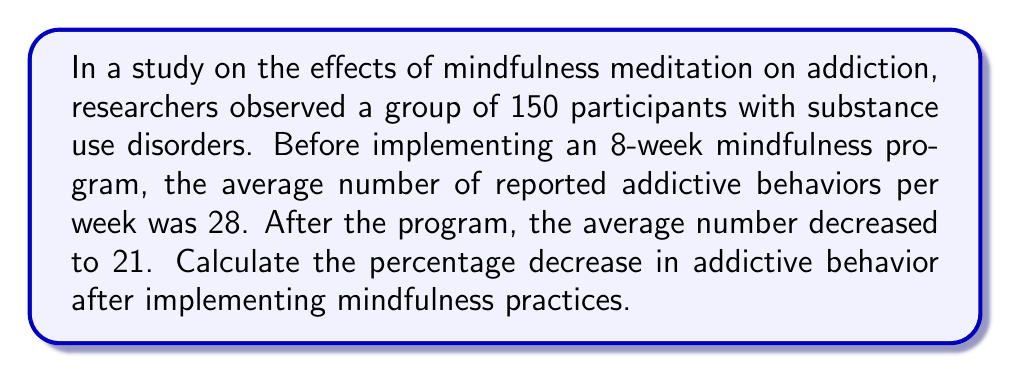Provide a solution to this math problem. To calculate the percentage decrease in addictive behavior, we'll follow these steps:

1. Identify the initial and final values:
   Initial value (before mindfulness): $i = 28$
   Final value (after mindfulness): $f = 21$

2. Calculate the decrease in absolute terms:
   Decrease = $i - f = 28 - 21 = 7$

3. Calculate the percentage decrease using the formula:
   Percentage decrease = $\frac{\text{Decrease}}{\text{Initial value}} \times 100\%$

4. Substitute the values into the formula:
   Percentage decrease = $\frac{7}{28} \times 100\%$

5. Simplify the fraction:
   $\frac{7}{28} = \frac{1}{4} = 0.25$

6. Calculate the final percentage:
   $0.25 \times 100\% = 25\%$

Therefore, the percentage decrease in addictive behavior after implementing mindfulness practices is 25%.
Answer: 25% 